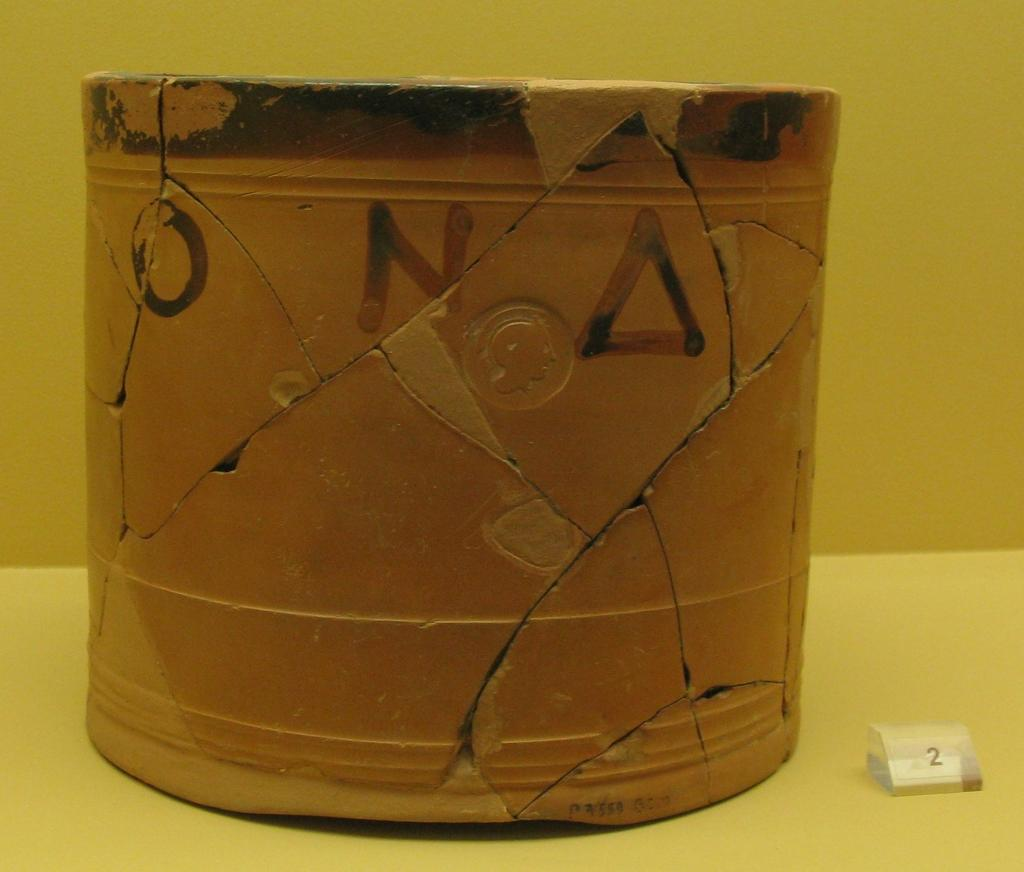<image>
Provide a brief description of the given image. a cracked small pop that has 'o' and 'n' and a triangle painted on it 